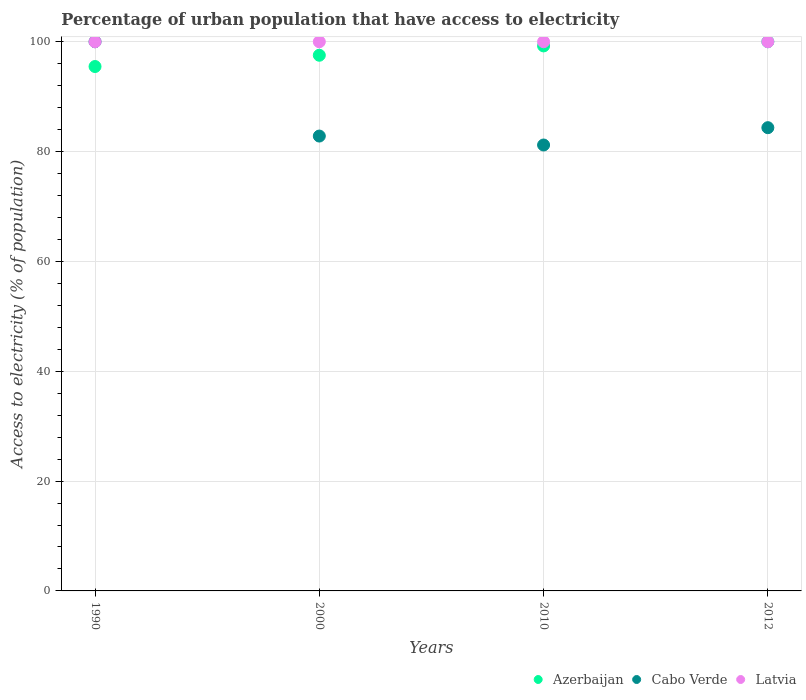Is the number of dotlines equal to the number of legend labels?
Offer a very short reply. Yes. What is the percentage of urban population that have access to electricity in Azerbaijan in 2012?
Ensure brevity in your answer.  100. Across all years, what is the maximum percentage of urban population that have access to electricity in Latvia?
Offer a very short reply. 100. Across all years, what is the minimum percentage of urban population that have access to electricity in Cabo Verde?
Your answer should be very brief. 81.2. In which year was the percentage of urban population that have access to electricity in Latvia minimum?
Your response must be concise. 1990. What is the total percentage of urban population that have access to electricity in Cabo Verde in the graph?
Offer a very short reply. 348.37. What is the difference between the percentage of urban population that have access to electricity in Cabo Verde in 2000 and that in 2012?
Offer a terse response. -1.53. What is the difference between the percentage of urban population that have access to electricity in Cabo Verde in 2012 and the percentage of urban population that have access to electricity in Latvia in 2010?
Ensure brevity in your answer.  -15.65. What is the average percentage of urban population that have access to electricity in Latvia per year?
Your response must be concise. 100. What is the ratio of the percentage of urban population that have access to electricity in Cabo Verde in 2010 to that in 2012?
Provide a succinct answer. 0.96. Is the percentage of urban population that have access to electricity in Cabo Verde in 2010 less than that in 2012?
Provide a succinct answer. Yes. Is the difference between the percentage of urban population that have access to electricity in Latvia in 1990 and 2000 greater than the difference between the percentage of urban population that have access to electricity in Azerbaijan in 1990 and 2000?
Your answer should be compact. Yes. What is the difference between the highest and the second highest percentage of urban population that have access to electricity in Azerbaijan?
Your response must be concise. 0.76. What is the difference between the highest and the lowest percentage of urban population that have access to electricity in Azerbaijan?
Provide a short and direct response. 4.51. Is it the case that in every year, the sum of the percentage of urban population that have access to electricity in Latvia and percentage of urban population that have access to electricity in Cabo Verde  is greater than the percentage of urban population that have access to electricity in Azerbaijan?
Offer a terse response. Yes. Does the percentage of urban population that have access to electricity in Cabo Verde monotonically increase over the years?
Ensure brevity in your answer.  No. Is the percentage of urban population that have access to electricity in Latvia strictly greater than the percentage of urban population that have access to electricity in Azerbaijan over the years?
Keep it short and to the point. No. Is the percentage of urban population that have access to electricity in Latvia strictly less than the percentage of urban population that have access to electricity in Azerbaijan over the years?
Offer a terse response. No. How many years are there in the graph?
Ensure brevity in your answer.  4. What is the difference between two consecutive major ticks on the Y-axis?
Provide a short and direct response. 20. Are the values on the major ticks of Y-axis written in scientific E-notation?
Your answer should be compact. No. How many legend labels are there?
Make the answer very short. 3. How are the legend labels stacked?
Provide a succinct answer. Horizontal. What is the title of the graph?
Offer a very short reply. Percentage of urban population that have access to electricity. Does "Sierra Leone" appear as one of the legend labels in the graph?
Keep it short and to the point. No. What is the label or title of the Y-axis?
Offer a terse response. Access to electricity (% of population). What is the Access to electricity (% of population) of Azerbaijan in 1990?
Provide a short and direct response. 95.49. What is the Access to electricity (% of population) in Azerbaijan in 2000?
Provide a succinct answer. 97.54. What is the Access to electricity (% of population) of Cabo Verde in 2000?
Your answer should be compact. 82.83. What is the Access to electricity (% of population) in Azerbaijan in 2010?
Your answer should be very brief. 99.24. What is the Access to electricity (% of population) in Cabo Verde in 2010?
Give a very brief answer. 81.2. What is the Access to electricity (% of population) of Latvia in 2010?
Provide a succinct answer. 100. What is the Access to electricity (% of population) of Cabo Verde in 2012?
Make the answer very short. 84.35. Across all years, what is the minimum Access to electricity (% of population) in Azerbaijan?
Make the answer very short. 95.49. Across all years, what is the minimum Access to electricity (% of population) in Cabo Verde?
Make the answer very short. 81.2. What is the total Access to electricity (% of population) in Azerbaijan in the graph?
Your answer should be compact. 392.27. What is the total Access to electricity (% of population) in Cabo Verde in the graph?
Ensure brevity in your answer.  348.37. What is the total Access to electricity (% of population) in Latvia in the graph?
Keep it short and to the point. 400. What is the difference between the Access to electricity (% of population) of Azerbaijan in 1990 and that in 2000?
Your response must be concise. -2.05. What is the difference between the Access to electricity (% of population) of Cabo Verde in 1990 and that in 2000?
Offer a terse response. 17.17. What is the difference between the Access to electricity (% of population) of Latvia in 1990 and that in 2000?
Offer a terse response. 0. What is the difference between the Access to electricity (% of population) of Azerbaijan in 1990 and that in 2010?
Ensure brevity in your answer.  -3.75. What is the difference between the Access to electricity (% of population) of Cabo Verde in 1990 and that in 2010?
Give a very brief answer. 18.8. What is the difference between the Access to electricity (% of population) of Azerbaijan in 1990 and that in 2012?
Provide a short and direct response. -4.51. What is the difference between the Access to electricity (% of population) of Cabo Verde in 1990 and that in 2012?
Your answer should be compact. 15.65. What is the difference between the Access to electricity (% of population) of Latvia in 1990 and that in 2012?
Offer a very short reply. 0. What is the difference between the Access to electricity (% of population) of Azerbaijan in 2000 and that in 2010?
Give a very brief answer. -1.7. What is the difference between the Access to electricity (% of population) in Cabo Verde in 2000 and that in 2010?
Your answer should be compact. 1.63. What is the difference between the Access to electricity (% of population) in Latvia in 2000 and that in 2010?
Offer a very short reply. 0. What is the difference between the Access to electricity (% of population) in Azerbaijan in 2000 and that in 2012?
Your answer should be very brief. -2.46. What is the difference between the Access to electricity (% of population) in Cabo Verde in 2000 and that in 2012?
Your answer should be very brief. -1.53. What is the difference between the Access to electricity (% of population) in Azerbaijan in 2010 and that in 2012?
Your answer should be compact. -0.76. What is the difference between the Access to electricity (% of population) in Cabo Verde in 2010 and that in 2012?
Offer a terse response. -3.15. What is the difference between the Access to electricity (% of population) in Latvia in 2010 and that in 2012?
Offer a very short reply. 0. What is the difference between the Access to electricity (% of population) in Azerbaijan in 1990 and the Access to electricity (% of population) in Cabo Verde in 2000?
Your answer should be very brief. 12.66. What is the difference between the Access to electricity (% of population) in Azerbaijan in 1990 and the Access to electricity (% of population) in Latvia in 2000?
Your answer should be compact. -4.51. What is the difference between the Access to electricity (% of population) of Azerbaijan in 1990 and the Access to electricity (% of population) of Cabo Verde in 2010?
Keep it short and to the point. 14.29. What is the difference between the Access to electricity (% of population) of Azerbaijan in 1990 and the Access to electricity (% of population) of Latvia in 2010?
Give a very brief answer. -4.51. What is the difference between the Access to electricity (% of population) of Cabo Verde in 1990 and the Access to electricity (% of population) of Latvia in 2010?
Your answer should be compact. 0. What is the difference between the Access to electricity (% of population) of Azerbaijan in 1990 and the Access to electricity (% of population) of Cabo Verde in 2012?
Your answer should be very brief. 11.14. What is the difference between the Access to electricity (% of population) of Azerbaijan in 1990 and the Access to electricity (% of population) of Latvia in 2012?
Ensure brevity in your answer.  -4.51. What is the difference between the Access to electricity (% of population) in Cabo Verde in 1990 and the Access to electricity (% of population) in Latvia in 2012?
Provide a short and direct response. 0. What is the difference between the Access to electricity (% of population) in Azerbaijan in 2000 and the Access to electricity (% of population) in Cabo Verde in 2010?
Offer a terse response. 16.34. What is the difference between the Access to electricity (% of population) in Azerbaijan in 2000 and the Access to electricity (% of population) in Latvia in 2010?
Ensure brevity in your answer.  -2.46. What is the difference between the Access to electricity (% of population) of Cabo Verde in 2000 and the Access to electricity (% of population) of Latvia in 2010?
Provide a succinct answer. -17.17. What is the difference between the Access to electricity (% of population) in Azerbaijan in 2000 and the Access to electricity (% of population) in Cabo Verde in 2012?
Provide a succinct answer. 13.19. What is the difference between the Access to electricity (% of population) in Azerbaijan in 2000 and the Access to electricity (% of population) in Latvia in 2012?
Provide a succinct answer. -2.46. What is the difference between the Access to electricity (% of population) of Cabo Verde in 2000 and the Access to electricity (% of population) of Latvia in 2012?
Provide a short and direct response. -17.17. What is the difference between the Access to electricity (% of population) in Azerbaijan in 2010 and the Access to electricity (% of population) in Cabo Verde in 2012?
Provide a short and direct response. 14.89. What is the difference between the Access to electricity (% of population) in Azerbaijan in 2010 and the Access to electricity (% of population) in Latvia in 2012?
Give a very brief answer. -0.76. What is the difference between the Access to electricity (% of population) in Cabo Verde in 2010 and the Access to electricity (% of population) in Latvia in 2012?
Your response must be concise. -18.8. What is the average Access to electricity (% of population) in Azerbaijan per year?
Provide a short and direct response. 98.07. What is the average Access to electricity (% of population) in Cabo Verde per year?
Make the answer very short. 87.09. In the year 1990, what is the difference between the Access to electricity (% of population) of Azerbaijan and Access to electricity (% of population) of Cabo Verde?
Provide a succinct answer. -4.51. In the year 1990, what is the difference between the Access to electricity (% of population) in Azerbaijan and Access to electricity (% of population) in Latvia?
Keep it short and to the point. -4.51. In the year 1990, what is the difference between the Access to electricity (% of population) of Cabo Verde and Access to electricity (% of population) of Latvia?
Offer a very short reply. 0. In the year 2000, what is the difference between the Access to electricity (% of population) of Azerbaijan and Access to electricity (% of population) of Cabo Verde?
Your answer should be very brief. 14.71. In the year 2000, what is the difference between the Access to electricity (% of population) of Azerbaijan and Access to electricity (% of population) of Latvia?
Keep it short and to the point. -2.46. In the year 2000, what is the difference between the Access to electricity (% of population) of Cabo Verde and Access to electricity (% of population) of Latvia?
Give a very brief answer. -17.17. In the year 2010, what is the difference between the Access to electricity (% of population) of Azerbaijan and Access to electricity (% of population) of Cabo Verde?
Ensure brevity in your answer.  18.04. In the year 2010, what is the difference between the Access to electricity (% of population) in Azerbaijan and Access to electricity (% of population) in Latvia?
Provide a succinct answer. -0.76. In the year 2010, what is the difference between the Access to electricity (% of population) of Cabo Verde and Access to electricity (% of population) of Latvia?
Provide a succinct answer. -18.8. In the year 2012, what is the difference between the Access to electricity (% of population) in Azerbaijan and Access to electricity (% of population) in Cabo Verde?
Your answer should be very brief. 15.65. In the year 2012, what is the difference between the Access to electricity (% of population) in Cabo Verde and Access to electricity (% of population) in Latvia?
Offer a very short reply. -15.65. What is the ratio of the Access to electricity (% of population) of Azerbaijan in 1990 to that in 2000?
Offer a terse response. 0.98. What is the ratio of the Access to electricity (% of population) of Cabo Verde in 1990 to that in 2000?
Keep it short and to the point. 1.21. What is the ratio of the Access to electricity (% of population) of Azerbaijan in 1990 to that in 2010?
Give a very brief answer. 0.96. What is the ratio of the Access to electricity (% of population) in Cabo Verde in 1990 to that in 2010?
Ensure brevity in your answer.  1.23. What is the ratio of the Access to electricity (% of population) of Latvia in 1990 to that in 2010?
Your response must be concise. 1. What is the ratio of the Access to electricity (% of population) in Azerbaijan in 1990 to that in 2012?
Make the answer very short. 0.95. What is the ratio of the Access to electricity (% of population) of Cabo Verde in 1990 to that in 2012?
Provide a succinct answer. 1.19. What is the ratio of the Access to electricity (% of population) of Azerbaijan in 2000 to that in 2010?
Ensure brevity in your answer.  0.98. What is the ratio of the Access to electricity (% of population) in Cabo Verde in 2000 to that in 2010?
Keep it short and to the point. 1.02. What is the ratio of the Access to electricity (% of population) in Azerbaijan in 2000 to that in 2012?
Give a very brief answer. 0.98. What is the ratio of the Access to electricity (% of population) in Cabo Verde in 2000 to that in 2012?
Ensure brevity in your answer.  0.98. What is the ratio of the Access to electricity (% of population) in Cabo Verde in 2010 to that in 2012?
Offer a terse response. 0.96. What is the difference between the highest and the second highest Access to electricity (% of population) of Azerbaijan?
Offer a very short reply. 0.76. What is the difference between the highest and the second highest Access to electricity (% of population) in Cabo Verde?
Your response must be concise. 15.65. What is the difference between the highest and the second highest Access to electricity (% of population) of Latvia?
Ensure brevity in your answer.  0. What is the difference between the highest and the lowest Access to electricity (% of population) of Azerbaijan?
Your answer should be compact. 4.51. What is the difference between the highest and the lowest Access to electricity (% of population) in Cabo Verde?
Offer a very short reply. 18.8. 